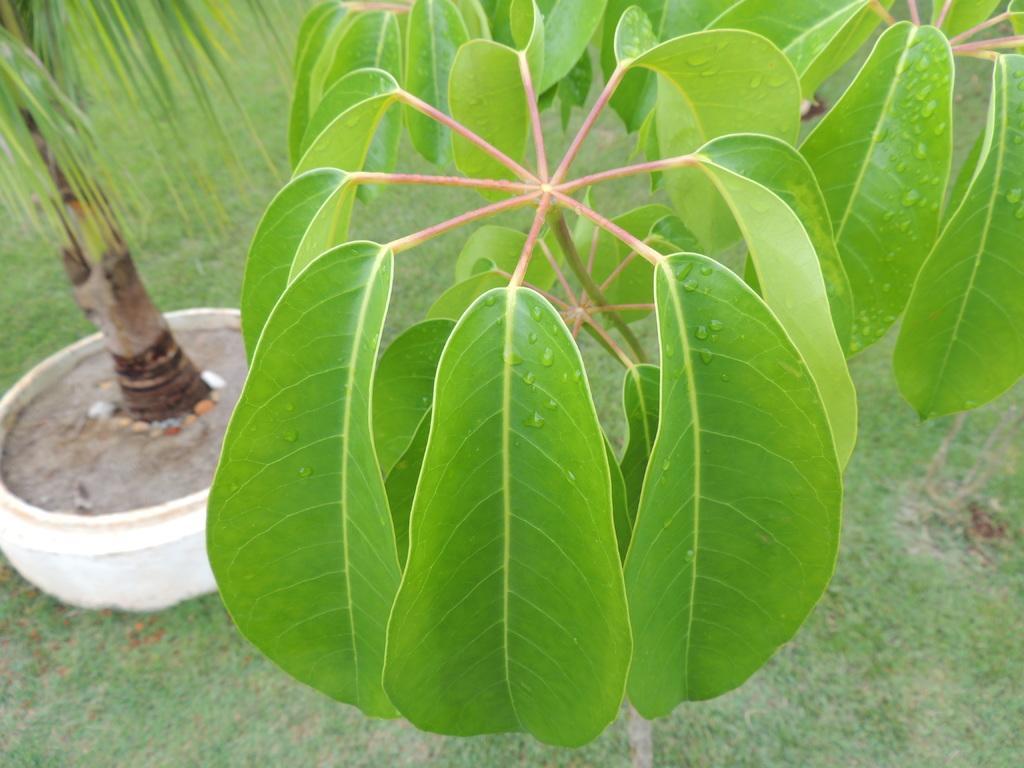Can you describe this image briefly? In this image I see number of plants and I see the grass and I see the white color thing over here on which there is a plant. 